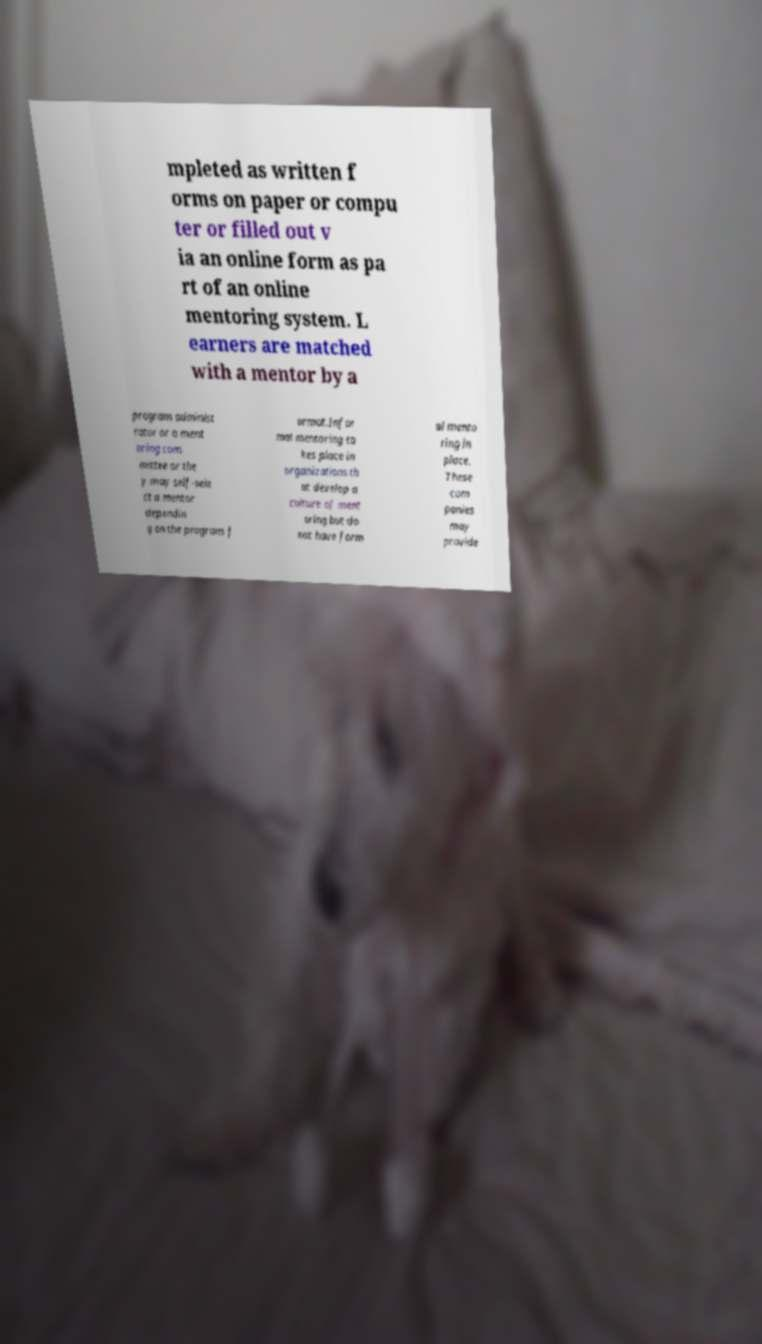Can you accurately transcribe the text from the provided image for me? mpleted as written f orms on paper or compu ter or filled out v ia an online form as pa rt of an online mentoring system. L earners are matched with a mentor by a program administ rator or a ment oring com mittee or the y may self-sele ct a mentor dependin g on the program f ormat.Infor mal mentoring ta kes place in organizations th at develop a culture of ment oring but do not have form al mento ring in place. These com panies may provide 